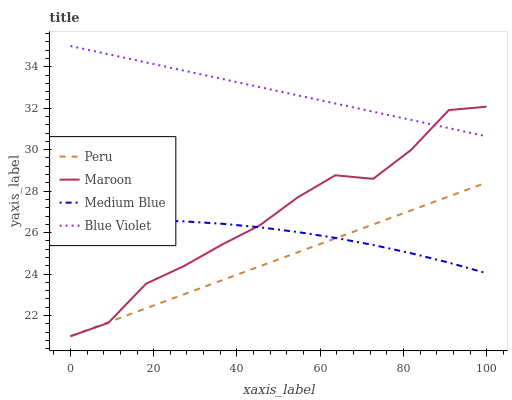Does Peru have the minimum area under the curve?
Answer yes or no. Yes. Does Blue Violet have the maximum area under the curve?
Answer yes or no. Yes. Does Medium Blue have the minimum area under the curve?
Answer yes or no. No. Does Medium Blue have the maximum area under the curve?
Answer yes or no. No. Is Peru the smoothest?
Answer yes or no. Yes. Is Maroon the roughest?
Answer yes or no. Yes. Is Medium Blue the smoothest?
Answer yes or no. No. Is Medium Blue the roughest?
Answer yes or no. No. Does Medium Blue have the lowest value?
Answer yes or no. No. Does Blue Violet have the highest value?
Answer yes or no. Yes. Does Maroon have the highest value?
Answer yes or no. No. Is Medium Blue less than Blue Violet?
Answer yes or no. Yes. Is Blue Violet greater than Peru?
Answer yes or no. Yes. Does Maroon intersect Blue Violet?
Answer yes or no. Yes. Is Maroon less than Blue Violet?
Answer yes or no. No. Is Maroon greater than Blue Violet?
Answer yes or no. No. Does Medium Blue intersect Blue Violet?
Answer yes or no. No. 